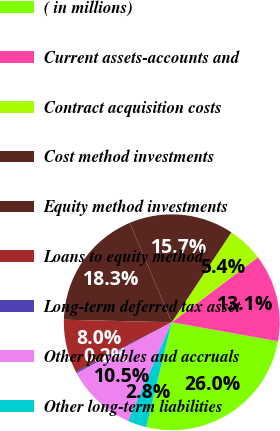<chart> <loc_0><loc_0><loc_500><loc_500><pie_chart><fcel>( in millions)<fcel>Current assets-accounts and<fcel>Contract acquisition costs<fcel>Cost method investments<fcel>Equity method investments<fcel>Loans to equity method<fcel>Long-term deferred tax asset<fcel>Other payables and accruals<fcel>Other long-term liabilities<nl><fcel>25.98%<fcel>13.11%<fcel>5.39%<fcel>15.69%<fcel>18.26%<fcel>7.97%<fcel>0.25%<fcel>10.54%<fcel>2.82%<nl></chart> 